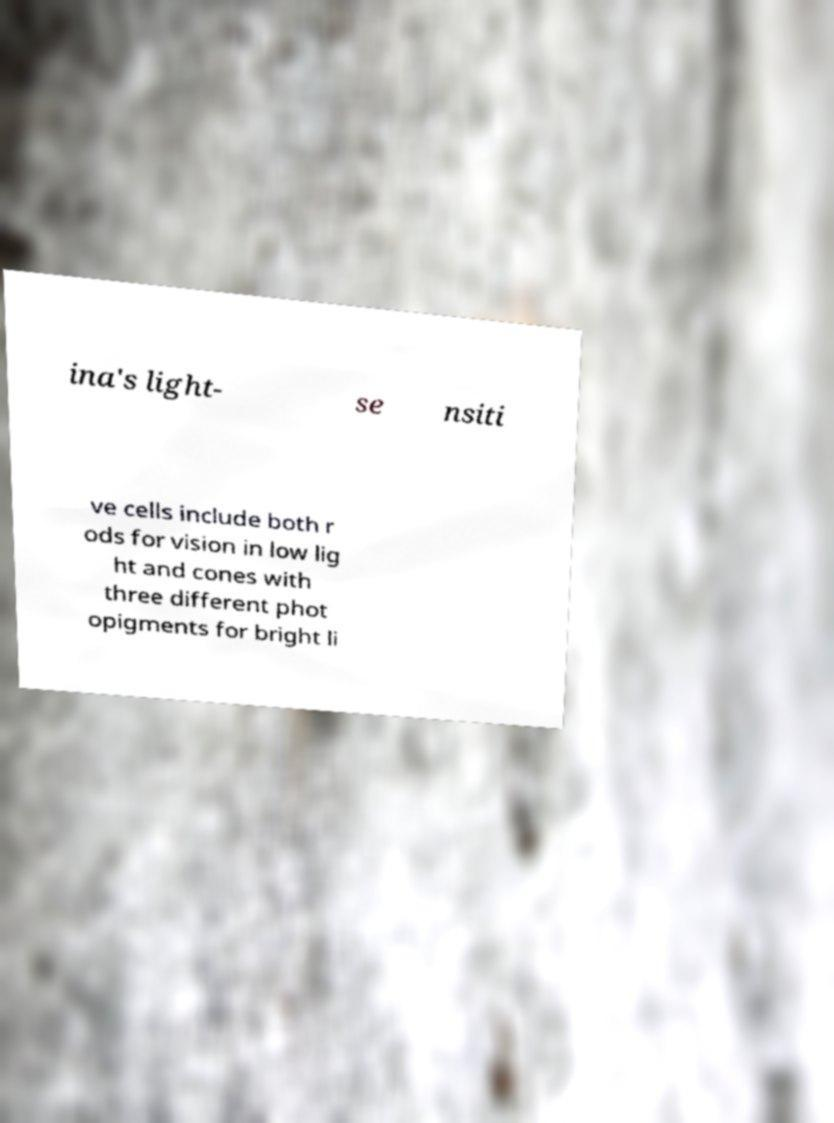Please read and relay the text visible in this image. What does it say? ina's light- se nsiti ve cells include both r ods for vision in low lig ht and cones with three different phot opigments for bright li 